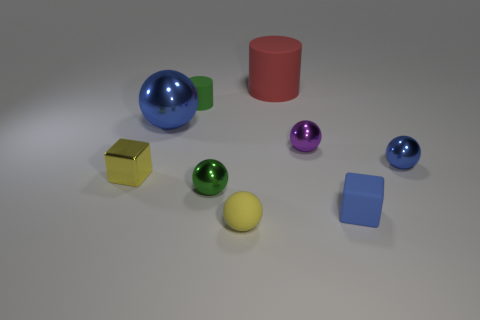What color is the matte thing that is left of the small blue rubber block and in front of the tiny green metallic ball?
Offer a terse response. Yellow. Are there any matte cylinders in front of the green object behind the tiny metal ball on the left side of the yellow sphere?
Make the answer very short. No. What is the size of the other object that is the same shape as the tiny green rubber thing?
Provide a succinct answer. Large. Are there any large green shiny cubes?
Provide a succinct answer. No. Do the rubber block and the small metallic sphere to the left of the purple ball have the same color?
Your answer should be very brief. No. What size is the blue thing to the left of the green thing right of the matte object that is on the left side of the yellow ball?
Provide a succinct answer. Large. How many tiny metallic spheres have the same color as the small rubber block?
Your response must be concise. 1. How many things are brown cylinders or small metal things that are right of the yellow rubber sphere?
Provide a succinct answer. 2. What color is the small metallic block?
Offer a terse response. Yellow. There is a metal thing that is on the left side of the big blue shiny sphere; what is its color?
Make the answer very short. Yellow. 